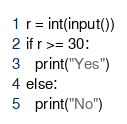<code> <loc_0><loc_0><loc_500><loc_500><_Python_>r = int(input())
if r >= 30:
  print("Yes")
else:
  print("No")
</code> 